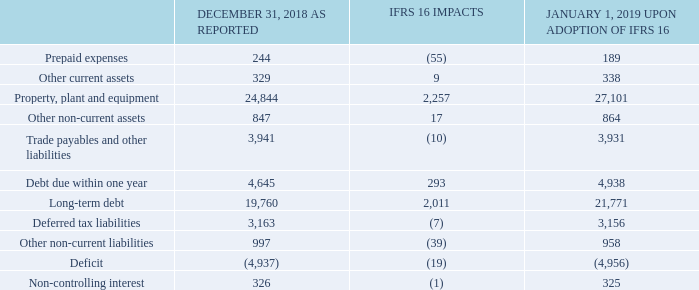ADOPTION OF IFRS 16
Upon adoption of IFRS 16 on January 1, 2019, we recognized right-of-use assets of $2,257 million within property, plant and equipment, and lease liabilities of $2,304 million within debt, with an increase to our deficit of $19 million. These amounts were recognized in addition to assets under finance leases of $1,947 million and the corresponding finance lease liabilities of $2,097 million at December 31, 2018 under IAS 17. As a result, on January 1, 2019, our total right-of-use assets and lease liabilities amounted to $4,204 million and $4,401 million, respectively. The table below shows the impacts of adopting IFRS 16 on our January 1, 2019 consolidated statement of financial position.
BCE’s operating lease commitments at December 31, 2018 were $1,612 million. The difference between operating lease commitments at December 31, 2018 and lease liabilities of $2,304 million upon adoption of IFRS 16 at January 1, 2019, is due mainly to an increase of $1,122 million related to renewal options reasonably certain to be exercised, an increase of $112 million mainly related to non-monetary transactions and a decrease of ($542) million as a result of discounting applied to future lease payments, which was determined using a weighted average incremental borrowing rate of 3.49% at January 1, 2019.
What is the amount of right-of-use assets recognized for property, plant and equipment under the adoption of IFRS 16 in 2019? $2,257 million. What are the prepaid expenses in 2019 upon adoption of IFRS 16?
Answer scale should be: million. 189. What is the weighted average incremental borrowing rate used to discount future lease payments? 3.49%. What is the total change between December 31, 2018 to January 1, 2019 due to the adoption of IFRS 16?
Answer scale should be: million. -55+9+2,257+17-10+293+2,011-7-39-19-1
Answer: 4456. What is the percentage change in other current assets due to the adoption of IFRS 16?
Answer scale should be: percent. (338-329)/329
Answer: 2.74. What is the percentage change in Debt due within one year due to the adoption of IFRS 16?
Answer scale should be: percent. (4,938-4,645)/4,645
Answer: 6.31. 